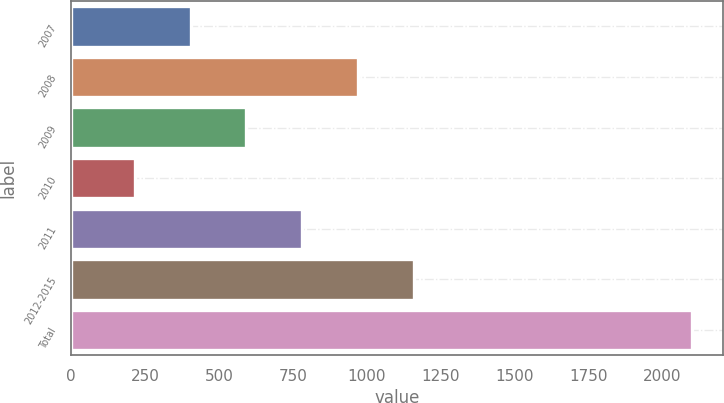<chart> <loc_0><loc_0><loc_500><loc_500><bar_chart><fcel>2007<fcel>2008<fcel>2009<fcel>2010<fcel>2011<fcel>2012-2015<fcel>Total<nl><fcel>404.6<fcel>970.4<fcel>593.2<fcel>216<fcel>781.8<fcel>1159<fcel>2102<nl></chart> 